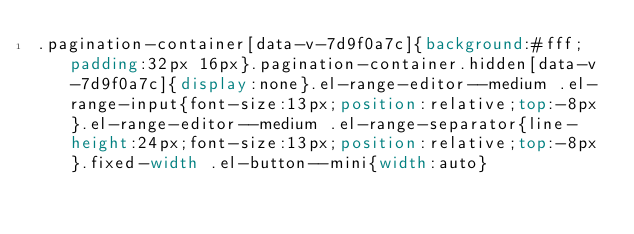<code> <loc_0><loc_0><loc_500><loc_500><_CSS_>.pagination-container[data-v-7d9f0a7c]{background:#fff;padding:32px 16px}.pagination-container.hidden[data-v-7d9f0a7c]{display:none}.el-range-editor--medium .el-range-input{font-size:13px;position:relative;top:-8px}.el-range-editor--medium .el-range-separator{line-height:24px;font-size:13px;position:relative;top:-8px}.fixed-width .el-button--mini{width:auto}</code> 